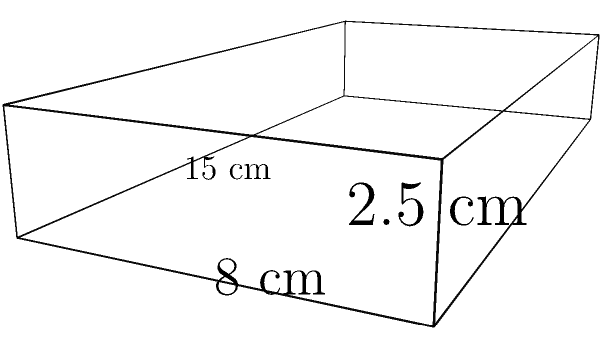You have a VHS tape of "The Night Of" starring John Turturro. The tape case measures 15 cm in length, 8 cm in width, and 2.5 cm in height. What is the volume of this rectangular prism-shaped VHS tape case in cubic centimeters? To calculate the volume of a rectangular prism, we need to multiply its length, width, and height.

Given:
- Length = 15 cm
- Width = 8 cm
- Height = 2.5 cm

Step 1: Apply the formula for the volume of a rectangular prism.
$$V = l \times w \times h$$

Step 2: Substitute the given values into the formula.
$$V = 15 \text{ cm} \times 8 \text{ cm} \times 2.5 \text{ cm}$$

Step 3: Multiply the numbers.
$$V = 300 \text{ cm}^3$$

Therefore, the volume of the VHS tape case is 300 cubic centimeters.
Answer: $300 \text{ cm}^3$ 